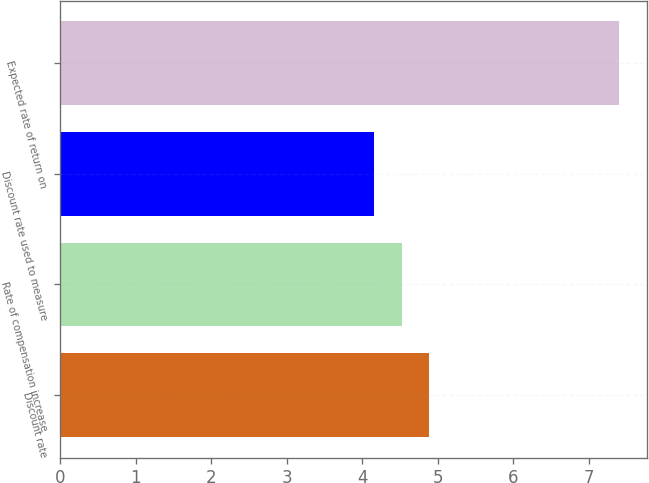<chart> <loc_0><loc_0><loc_500><loc_500><bar_chart><fcel>Discount rate<fcel>Rate of compensation increase<fcel>Discount rate used to measure<fcel>Expected rate of return on<nl><fcel>4.88<fcel>4.52<fcel>4.16<fcel>7.4<nl></chart> 